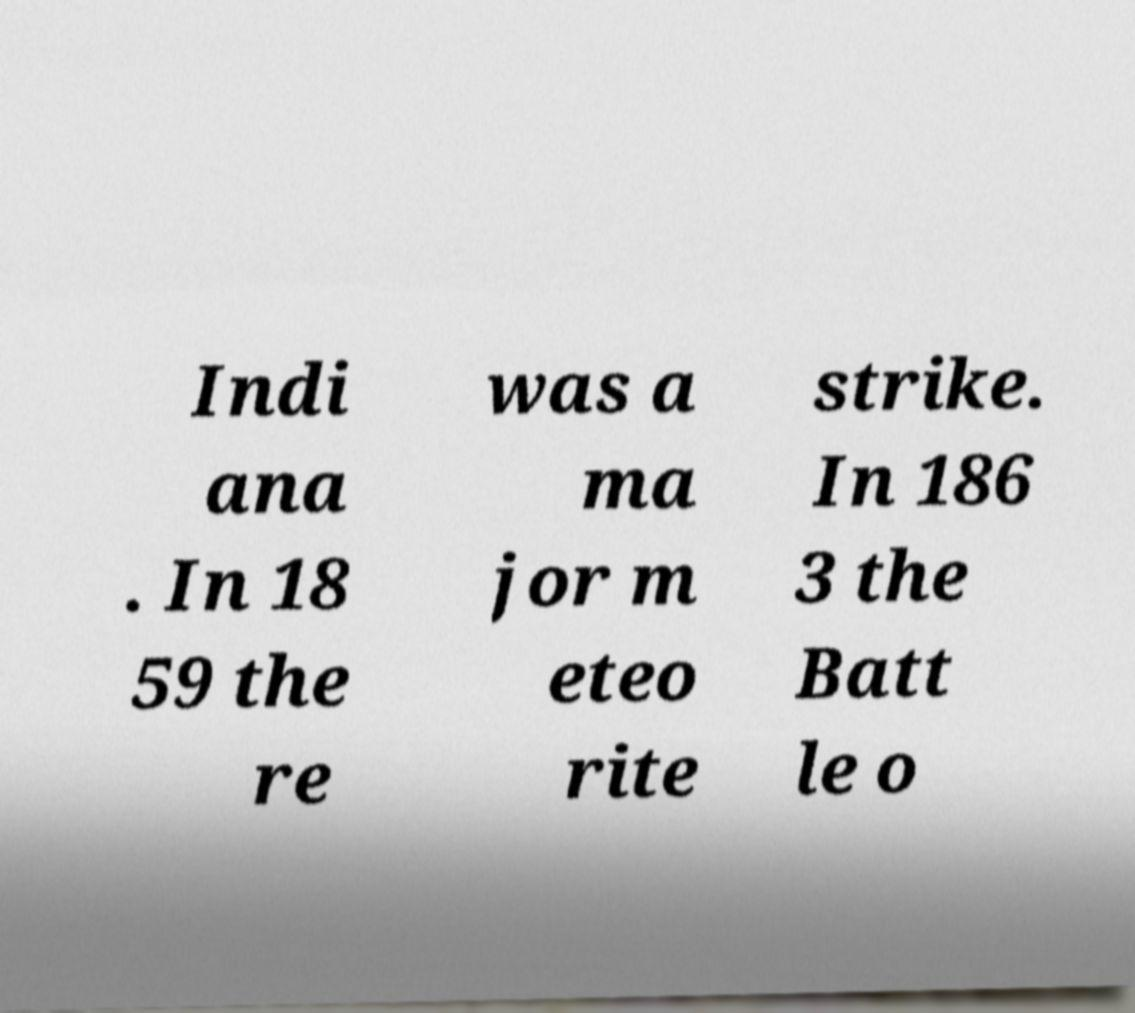Could you extract and type out the text from this image? Indi ana . In 18 59 the re was a ma jor m eteo rite strike. In 186 3 the Batt le o 